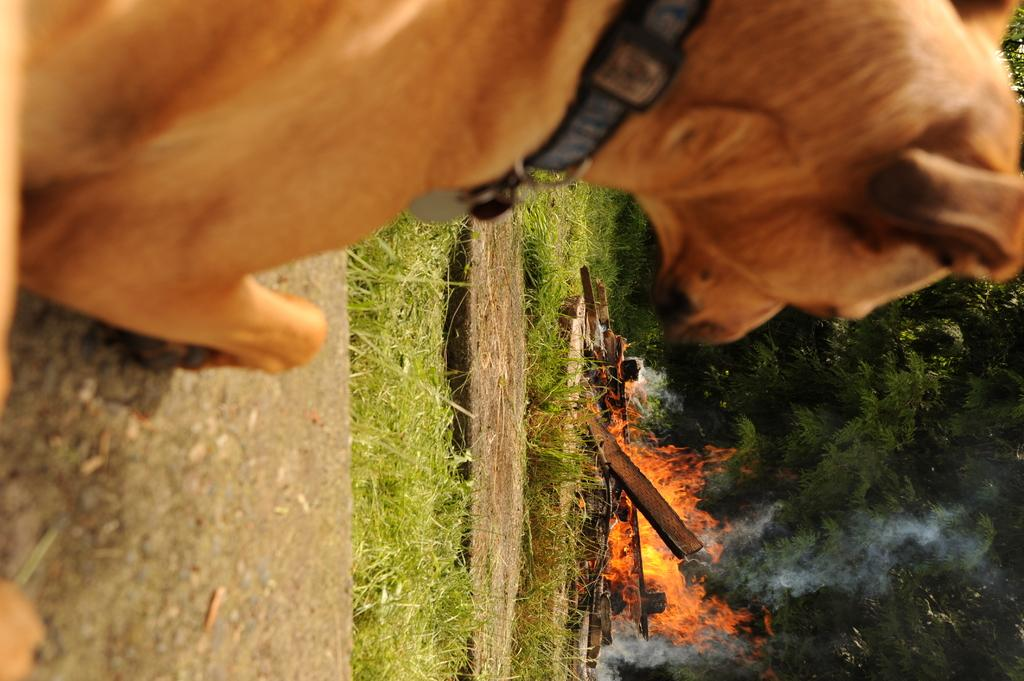What animal is located on the left side of the image? There is a dog on the left side of the image. What can be seen on the right side of the image? There is fire and smoke on the right side of the image. What type of vegetation is present in the image? There are trees in the image. What is the ground covered with in the image? There is grass on the ground in the image. What type of powder is being used to extinguish the fire in the image? There is no powder visible in the image; the fire is not being extinguished. What type of fruit is hanging from the trees in the image? There is no fruit visible on the trees in the image. 